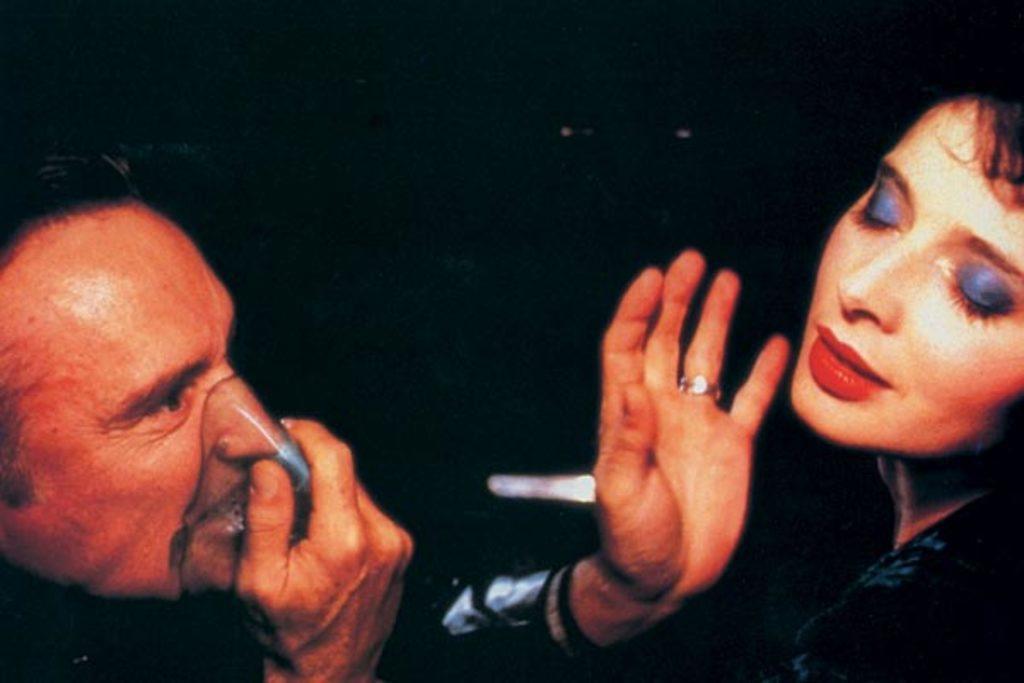Describe this image in one or two sentences. In this picture we can see a there are two people and behind the people there is a dark background. 